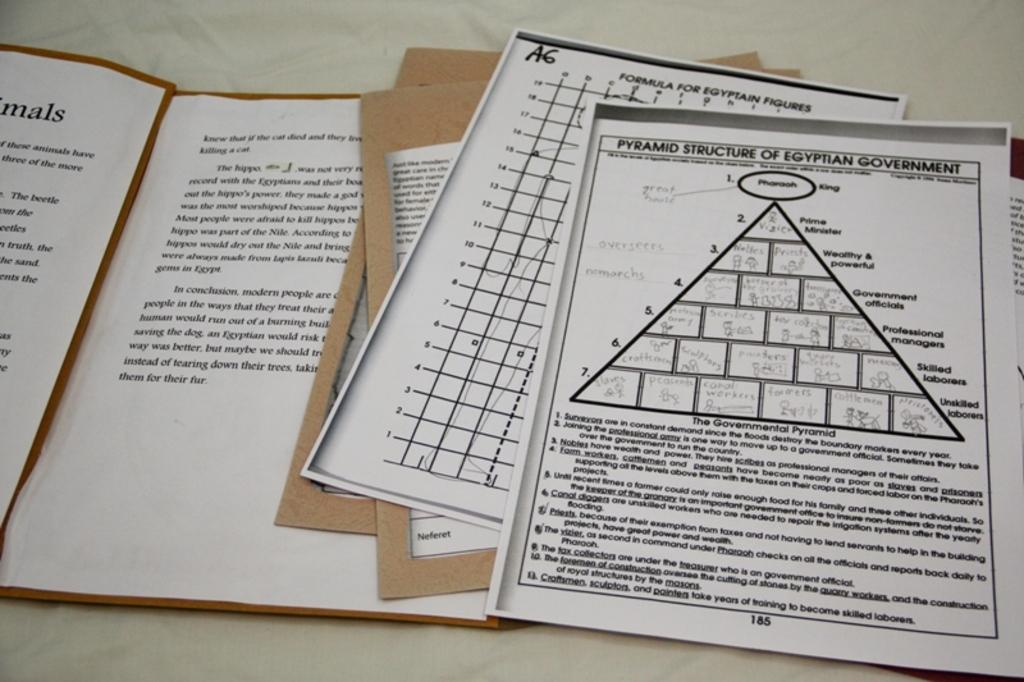Provide a one-sentence caption for the provided image. A group of white sheets with the top image reading Pyramid Structure on it. 